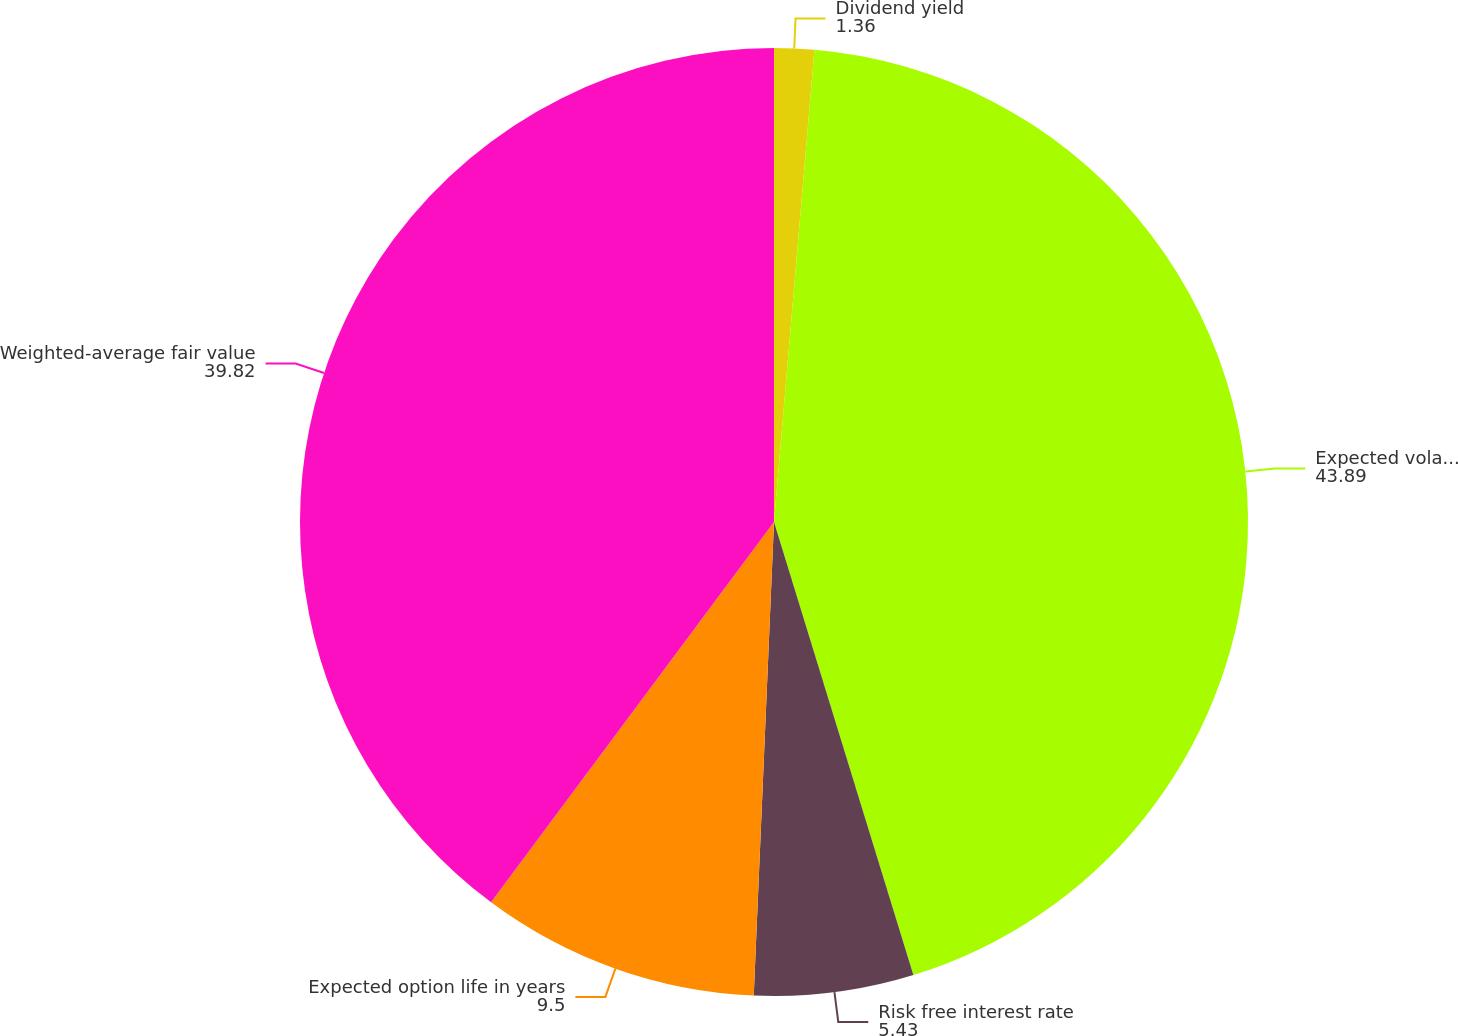Convert chart. <chart><loc_0><loc_0><loc_500><loc_500><pie_chart><fcel>Dividend yield<fcel>Expected volatility<fcel>Risk free interest rate<fcel>Expected option life in years<fcel>Weighted-average fair value<nl><fcel>1.36%<fcel>43.89%<fcel>5.43%<fcel>9.5%<fcel>39.82%<nl></chart> 